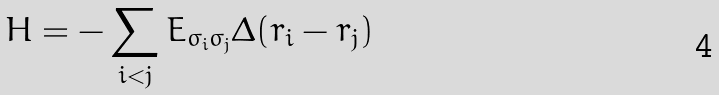Convert formula to latex. <formula><loc_0><loc_0><loc_500><loc_500>H = - \sum _ { i < j } E _ { \sigma _ { i } \sigma _ { j } } \Delta ( r _ { i } - r _ { j } )</formula> 